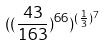<formula> <loc_0><loc_0><loc_500><loc_500>( ( \frac { 4 3 } { 1 6 3 } ) ^ { 6 6 } ) ^ { ( \frac { 1 } { 3 } ) ^ { 7 } }</formula> 